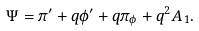Convert formula to latex. <formula><loc_0><loc_0><loc_500><loc_500>\Psi = \pi ^ { \prime } + q \phi ^ { \prime } + q \pi _ { \phi } + q ^ { 2 } A _ { 1 } .</formula> 